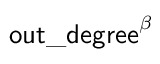<formula> <loc_0><loc_0><loc_500><loc_500>o u t \_ d e g r e e ^ { \beta }</formula> 